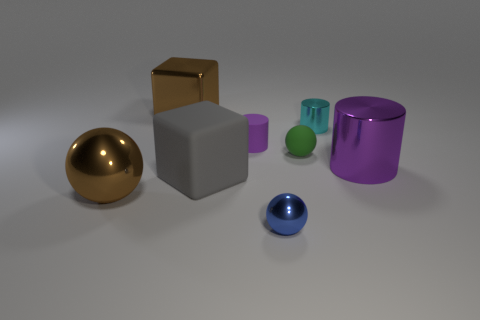Are there more large purple metal things that are in front of the brown metal sphere than rubber objects that are to the left of the matte cylinder?
Offer a terse response. No. There is a metallic ball to the left of the brown metal thing behind the small purple rubber object; what color is it?
Your answer should be compact. Brown. Are there any metallic cubes that have the same color as the large ball?
Ensure brevity in your answer.  Yes. How big is the brown object that is in front of the purple object to the left of the sphere behind the big brown sphere?
Give a very brief answer. Large. The blue object has what shape?
Your answer should be compact. Sphere. What is the size of the other cylinder that is the same color as the big metallic cylinder?
Make the answer very short. Small. There is a large thing behind the small cyan object; what number of metal cubes are right of it?
Offer a terse response. 0. What number of other things are made of the same material as the tiny cyan thing?
Provide a short and direct response. 4. Are the large brown object left of the metal cube and the purple object that is behind the green rubber object made of the same material?
Make the answer very short. No. Are there any other things that have the same shape as the green rubber thing?
Provide a succinct answer. Yes. 